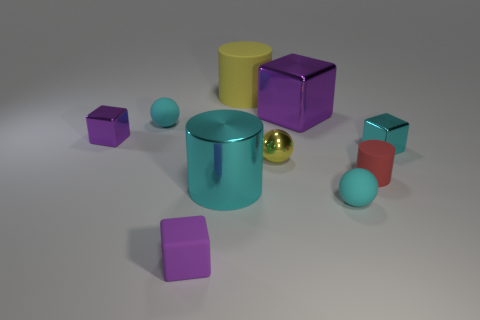Is the number of small red cylinders greater than the number of large gray matte cubes?
Make the answer very short. Yes. There is a cyan metal thing that is on the left side of the large matte cylinder; does it have the same shape as the large yellow object?
Offer a terse response. Yes. What number of shiny objects are either yellow objects or big cubes?
Offer a very short reply. 2. Is there a large brown ball made of the same material as the small cylinder?
Ensure brevity in your answer.  No. What is the material of the cyan block?
Your answer should be compact. Metal. The small cyan rubber thing that is behind the cyan matte object on the right side of the tiny matte object that is to the left of the tiny purple rubber cube is what shape?
Offer a very short reply. Sphere. Is the number of cyan objects to the left of the red cylinder greater than the number of big matte balls?
Give a very brief answer. Yes. There is a tiny purple rubber thing; does it have the same shape as the red rubber thing on the right side of the tiny yellow sphere?
Offer a very short reply. No. What shape is the tiny metal object that is the same color as the large rubber thing?
Keep it short and to the point. Sphere. There is a tiny purple block behind the small cube in front of the tiny cyan metal cube; how many tiny red rubber cylinders are to the right of it?
Your answer should be very brief. 1. 